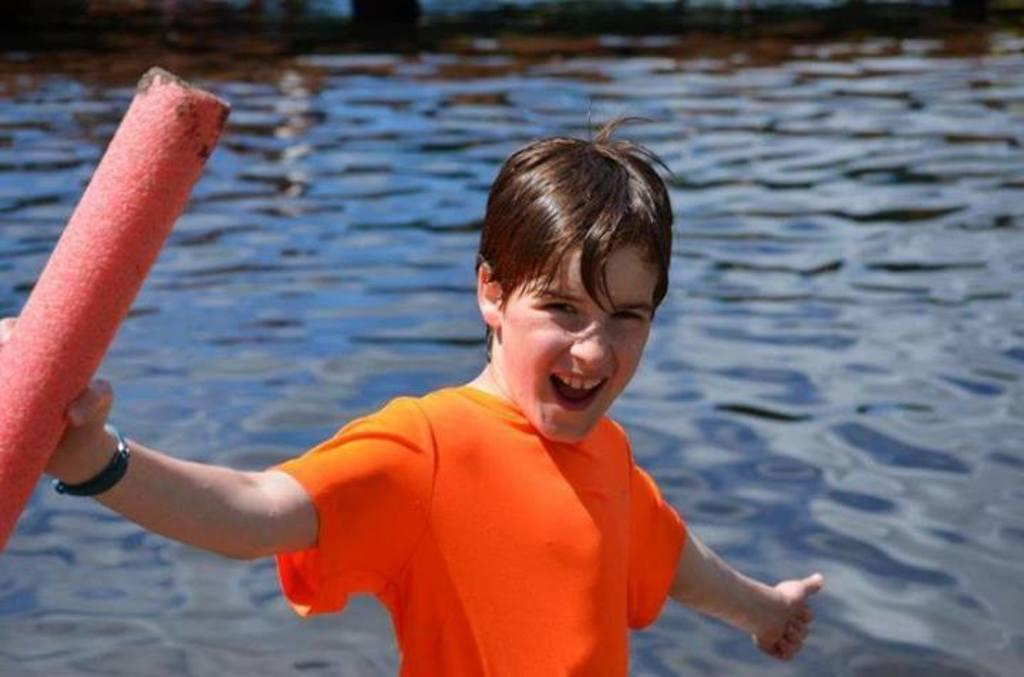Who is present in the image? There is a boy in the image. What is the boy holding in the image? The boy is holding an object. What can be seen in the background of the image? There is water visible behind the boy. What grade of salt is being used by the boy in the image? There is no salt present in the image, and the boy is not using any salt. 